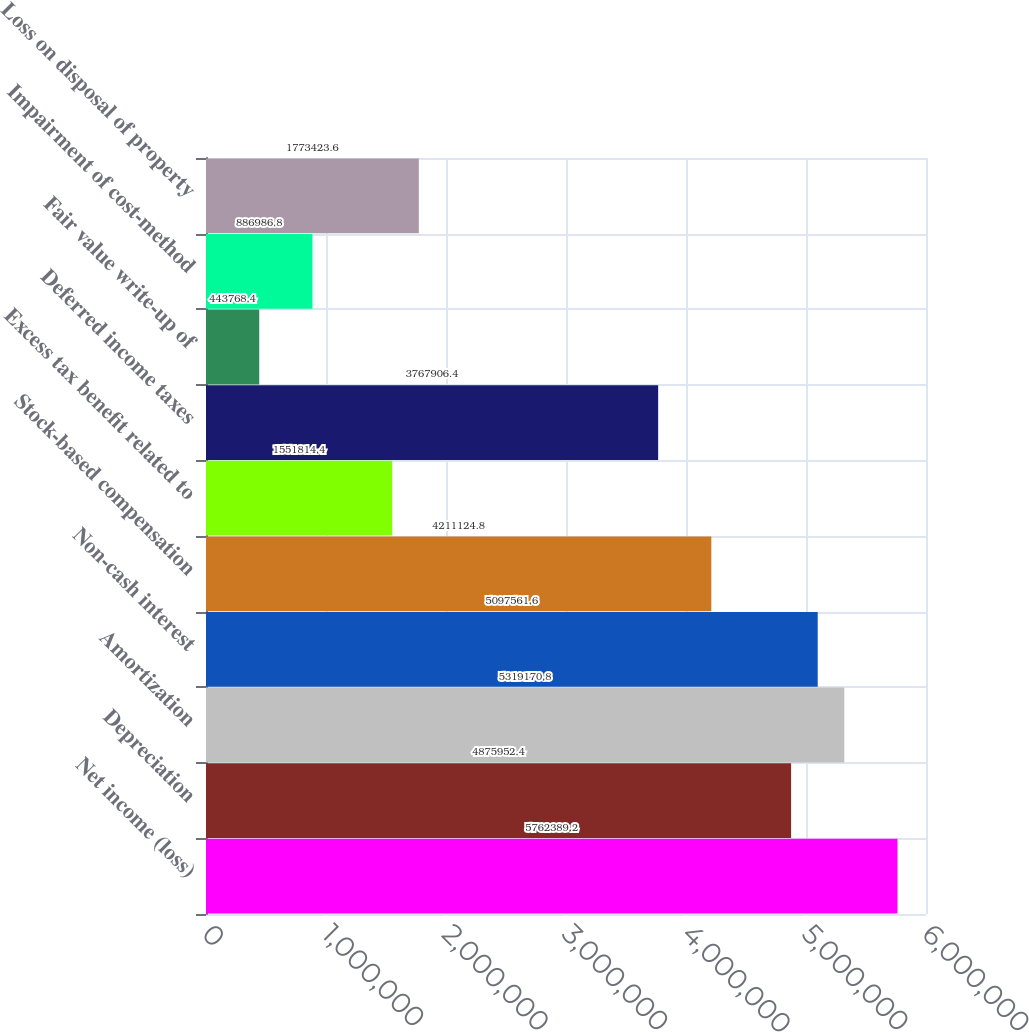Convert chart. <chart><loc_0><loc_0><loc_500><loc_500><bar_chart><fcel>Net income (loss)<fcel>Depreciation<fcel>Amortization<fcel>Non-cash interest<fcel>Stock-based compensation<fcel>Excess tax benefit related to<fcel>Deferred income taxes<fcel>Fair value write-up of<fcel>Impairment of cost-method<fcel>Loss on disposal of property<nl><fcel>5.76239e+06<fcel>4.87595e+06<fcel>5.31917e+06<fcel>5.09756e+06<fcel>4.21112e+06<fcel>1.55181e+06<fcel>3.76791e+06<fcel>443768<fcel>886987<fcel>1.77342e+06<nl></chart> 